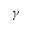<formula> <loc_0><loc_0><loc_500><loc_500>\gamma</formula> 